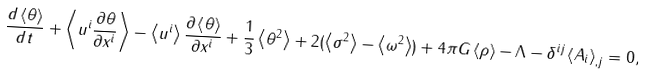Convert formula to latex. <formula><loc_0><loc_0><loc_500><loc_500>\frac { d \left \langle \theta \right \rangle } { d t } + \left \langle u ^ { i } \frac { \partial \theta } { \partial x ^ { i } } \right \rangle - \left \langle u ^ { i } \right \rangle \frac { \partial \left \langle \theta \right \rangle } { \partial x ^ { i } } + \frac { 1 } { 3 } \left \langle \theta ^ { 2 } \right \rangle + 2 ( \left \langle \sigma ^ { 2 } \right \rangle - \left \langle \omega ^ { 2 } \right \rangle ) + 4 \pi G \left \langle \rho \right \rangle - \Lambda - \delta ^ { i j } \left \langle A _ { i } \right \rangle _ { , j } = 0 ,</formula> 